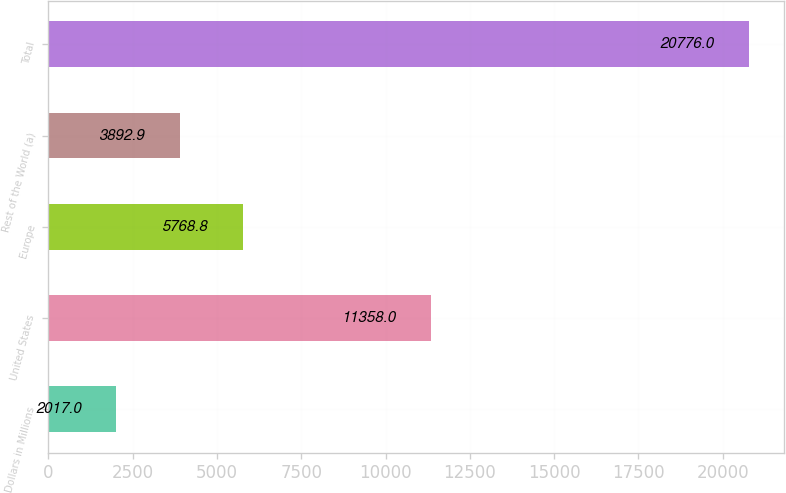Convert chart. <chart><loc_0><loc_0><loc_500><loc_500><bar_chart><fcel>Dollars in Millions<fcel>United States<fcel>Europe<fcel>Rest of the World (a)<fcel>Total<nl><fcel>2017<fcel>11358<fcel>5768.8<fcel>3892.9<fcel>20776<nl></chart> 